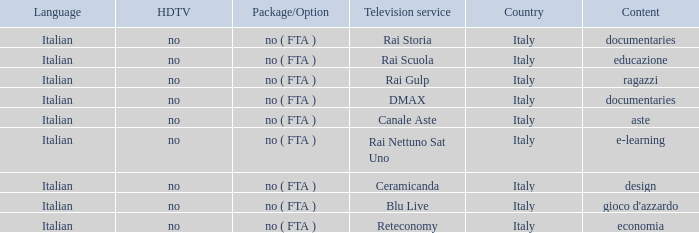What is the HDTV when documentaries are the content? No, no. 